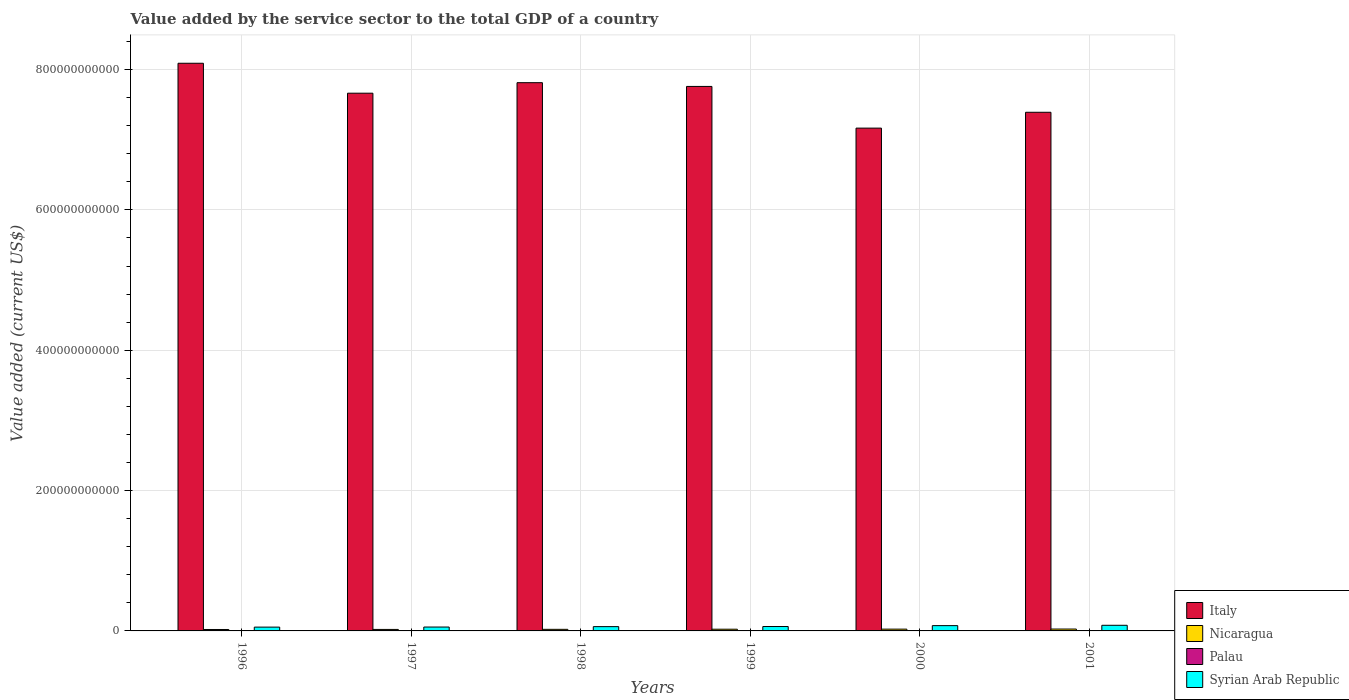How many different coloured bars are there?
Ensure brevity in your answer.  4. How many groups of bars are there?
Your response must be concise. 6. How many bars are there on the 5th tick from the left?
Make the answer very short. 4. How many bars are there on the 6th tick from the right?
Your response must be concise. 4. In how many cases, is the number of bars for a given year not equal to the number of legend labels?
Offer a terse response. 0. What is the value added by the service sector to the total GDP in Syrian Arab Republic in 2000?
Provide a succinct answer. 7.53e+09. Across all years, what is the maximum value added by the service sector to the total GDP in Italy?
Offer a terse response. 8.09e+11. Across all years, what is the minimum value added by the service sector to the total GDP in Nicaragua?
Offer a terse response. 2.03e+09. What is the total value added by the service sector to the total GDP in Palau in the graph?
Offer a very short reply. 5.96e+08. What is the difference between the value added by the service sector to the total GDP in Italy in 1996 and that in 1999?
Offer a terse response. 3.30e+1. What is the difference between the value added by the service sector to the total GDP in Italy in 2000 and the value added by the service sector to the total GDP in Palau in 1998?
Your answer should be compact. 7.16e+11. What is the average value added by the service sector to the total GDP in Syrian Arab Republic per year?
Your response must be concise. 6.48e+09. In the year 2000, what is the difference between the value added by the service sector to the total GDP in Nicaragua and value added by the service sector to the total GDP in Italy?
Provide a succinct answer. -7.14e+11. What is the ratio of the value added by the service sector to the total GDP in Palau in 1997 to that in 1998?
Ensure brevity in your answer.  1.01. Is the difference between the value added by the service sector to the total GDP in Nicaragua in 1996 and 2001 greater than the difference between the value added by the service sector to the total GDP in Italy in 1996 and 2001?
Offer a terse response. No. What is the difference between the highest and the second highest value added by the service sector to the total GDP in Italy?
Offer a very short reply. 2.77e+1. What is the difference between the highest and the lowest value added by the service sector to the total GDP in Nicaragua?
Ensure brevity in your answer.  6.43e+08. Is it the case that in every year, the sum of the value added by the service sector to the total GDP in Palau and value added by the service sector to the total GDP in Nicaragua is greater than the sum of value added by the service sector to the total GDP in Italy and value added by the service sector to the total GDP in Syrian Arab Republic?
Your answer should be compact. No. What does the 4th bar from the left in 1998 represents?
Provide a short and direct response. Syrian Arab Republic. What does the 1st bar from the right in 1997 represents?
Ensure brevity in your answer.  Syrian Arab Republic. Is it the case that in every year, the sum of the value added by the service sector to the total GDP in Syrian Arab Republic and value added by the service sector to the total GDP in Italy is greater than the value added by the service sector to the total GDP in Nicaragua?
Offer a very short reply. Yes. How many bars are there?
Make the answer very short. 24. How many years are there in the graph?
Your answer should be compact. 6. What is the difference between two consecutive major ticks on the Y-axis?
Give a very brief answer. 2.00e+11. Are the values on the major ticks of Y-axis written in scientific E-notation?
Offer a terse response. No. Does the graph contain any zero values?
Your answer should be compact. No. Does the graph contain grids?
Your response must be concise. Yes. What is the title of the graph?
Provide a succinct answer. Value added by the service sector to the total GDP of a country. Does "Zimbabwe" appear as one of the legend labels in the graph?
Provide a short and direct response. No. What is the label or title of the X-axis?
Offer a very short reply. Years. What is the label or title of the Y-axis?
Offer a very short reply. Value added (current US$). What is the Value added (current US$) in Italy in 1996?
Offer a terse response. 8.09e+11. What is the Value added (current US$) of Nicaragua in 1996?
Offer a terse response. 2.03e+09. What is the Value added (current US$) in Palau in 1996?
Provide a short and direct response. 9.31e+07. What is the Value added (current US$) in Syrian Arab Republic in 1996?
Give a very brief answer. 5.42e+09. What is the Value added (current US$) of Italy in 1997?
Give a very brief answer. 7.66e+11. What is the Value added (current US$) in Nicaragua in 1997?
Your answer should be compact. 2.13e+09. What is the Value added (current US$) in Palau in 1997?
Make the answer very short. 9.81e+07. What is the Value added (current US$) in Syrian Arab Republic in 1997?
Make the answer very short. 5.53e+09. What is the Value added (current US$) of Italy in 1998?
Your response must be concise. 7.81e+11. What is the Value added (current US$) in Nicaragua in 1998?
Offer a terse response. 2.26e+09. What is the Value added (current US$) in Palau in 1998?
Ensure brevity in your answer.  9.70e+07. What is the Value added (current US$) in Syrian Arab Republic in 1998?
Provide a succinct answer. 6.11e+09. What is the Value added (current US$) of Italy in 1999?
Provide a short and direct response. 7.76e+11. What is the Value added (current US$) in Nicaragua in 1999?
Make the answer very short. 2.44e+09. What is the Value added (current US$) of Palau in 1999?
Ensure brevity in your answer.  9.29e+07. What is the Value added (current US$) in Syrian Arab Republic in 1999?
Make the answer very short. 6.27e+09. What is the Value added (current US$) in Italy in 2000?
Your answer should be very brief. 7.16e+11. What is the Value added (current US$) of Nicaragua in 2000?
Provide a short and direct response. 2.54e+09. What is the Value added (current US$) in Palau in 2000?
Offer a terse response. 1.06e+08. What is the Value added (current US$) in Syrian Arab Republic in 2000?
Give a very brief answer. 7.53e+09. What is the Value added (current US$) of Italy in 2001?
Make the answer very short. 7.39e+11. What is the Value added (current US$) of Nicaragua in 2001?
Make the answer very short. 2.68e+09. What is the Value added (current US$) in Palau in 2001?
Give a very brief answer. 1.09e+08. What is the Value added (current US$) in Syrian Arab Republic in 2001?
Your answer should be compact. 8.02e+09. Across all years, what is the maximum Value added (current US$) of Italy?
Provide a succinct answer. 8.09e+11. Across all years, what is the maximum Value added (current US$) of Nicaragua?
Provide a succinct answer. 2.68e+09. Across all years, what is the maximum Value added (current US$) in Palau?
Ensure brevity in your answer.  1.09e+08. Across all years, what is the maximum Value added (current US$) in Syrian Arab Republic?
Keep it short and to the point. 8.02e+09. Across all years, what is the minimum Value added (current US$) of Italy?
Provide a succinct answer. 7.16e+11. Across all years, what is the minimum Value added (current US$) in Nicaragua?
Make the answer very short. 2.03e+09. Across all years, what is the minimum Value added (current US$) in Palau?
Offer a very short reply. 9.29e+07. Across all years, what is the minimum Value added (current US$) of Syrian Arab Republic?
Provide a short and direct response. 5.42e+09. What is the total Value added (current US$) in Italy in the graph?
Provide a succinct answer. 4.59e+12. What is the total Value added (current US$) of Nicaragua in the graph?
Keep it short and to the point. 1.41e+1. What is the total Value added (current US$) in Palau in the graph?
Your response must be concise. 5.96e+08. What is the total Value added (current US$) in Syrian Arab Republic in the graph?
Your response must be concise. 3.89e+1. What is the difference between the Value added (current US$) of Italy in 1996 and that in 1997?
Provide a succinct answer. 4.27e+1. What is the difference between the Value added (current US$) in Nicaragua in 1996 and that in 1997?
Provide a short and direct response. -9.48e+07. What is the difference between the Value added (current US$) in Palau in 1996 and that in 1997?
Your answer should be very brief. -5.01e+06. What is the difference between the Value added (current US$) of Syrian Arab Republic in 1996 and that in 1997?
Your response must be concise. -1.07e+08. What is the difference between the Value added (current US$) in Italy in 1996 and that in 1998?
Your answer should be compact. 2.77e+1. What is the difference between the Value added (current US$) of Nicaragua in 1996 and that in 1998?
Provide a short and direct response. -2.27e+08. What is the difference between the Value added (current US$) of Palau in 1996 and that in 1998?
Give a very brief answer. -3.92e+06. What is the difference between the Value added (current US$) in Syrian Arab Republic in 1996 and that in 1998?
Provide a short and direct response. -6.88e+08. What is the difference between the Value added (current US$) in Italy in 1996 and that in 1999?
Give a very brief answer. 3.30e+1. What is the difference between the Value added (current US$) of Nicaragua in 1996 and that in 1999?
Ensure brevity in your answer.  -4.00e+08. What is the difference between the Value added (current US$) in Palau in 1996 and that in 1999?
Your answer should be very brief. 1.87e+05. What is the difference between the Value added (current US$) of Syrian Arab Republic in 1996 and that in 1999?
Offer a terse response. -8.47e+08. What is the difference between the Value added (current US$) of Italy in 1996 and that in 2000?
Offer a terse response. 9.24e+1. What is the difference between the Value added (current US$) of Nicaragua in 1996 and that in 2000?
Ensure brevity in your answer.  -5.05e+08. What is the difference between the Value added (current US$) of Palau in 1996 and that in 2000?
Ensure brevity in your answer.  -1.26e+07. What is the difference between the Value added (current US$) of Syrian Arab Republic in 1996 and that in 2000?
Provide a short and direct response. -2.11e+09. What is the difference between the Value added (current US$) in Italy in 1996 and that in 2001?
Your answer should be compact. 6.98e+1. What is the difference between the Value added (current US$) in Nicaragua in 1996 and that in 2001?
Ensure brevity in your answer.  -6.43e+08. What is the difference between the Value added (current US$) in Palau in 1996 and that in 2001?
Offer a very short reply. -1.62e+07. What is the difference between the Value added (current US$) of Syrian Arab Republic in 1996 and that in 2001?
Offer a very short reply. -2.60e+09. What is the difference between the Value added (current US$) of Italy in 1997 and that in 1998?
Offer a very short reply. -1.50e+1. What is the difference between the Value added (current US$) of Nicaragua in 1997 and that in 1998?
Ensure brevity in your answer.  -1.32e+08. What is the difference between the Value added (current US$) in Palau in 1997 and that in 1998?
Give a very brief answer. 1.09e+06. What is the difference between the Value added (current US$) in Syrian Arab Republic in 1997 and that in 1998?
Keep it short and to the point. -5.80e+08. What is the difference between the Value added (current US$) in Italy in 1997 and that in 1999?
Keep it short and to the point. -9.65e+09. What is the difference between the Value added (current US$) in Nicaragua in 1997 and that in 1999?
Keep it short and to the point. -3.06e+08. What is the difference between the Value added (current US$) in Palau in 1997 and that in 1999?
Keep it short and to the point. 5.19e+06. What is the difference between the Value added (current US$) of Syrian Arab Republic in 1997 and that in 1999?
Your answer should be compact. -7.39e+08. What is the difference between the Value added (current US$) of Italy in 1997 and that in 2000?
Give a very brief answer. 4.98e+1. What is the difference between the Value added (current US$) in Nicaragua in 1997 and that in 2000?
Provide a short and direct response. -4.11e+08. What is the difference between the Value added (current US$) of Palau in 1997 and that in 2000?
Provide a short and direct response. -7.60e+06. What is the difference between the Value added (current US$) of Syrian Arab Republic in 1997 and that in 2000?
Offer a terse response. -2.00e+09. What is the difference between the Value added (current US$) of Italy in 1997 and that in 2001?
Keep it short and to the point. 2.72e+1. What is the difference between the Value added (current US$) in Nicaragua in 1997 and that in 2001?
Keep it short and to the point. -5.48e+08. What is the difference between the Value added (current US$) of Palau in 1997 and that in 2001?
Your answer should be compact. -1.11e+07. What is the difference between the Value added (current US$) of Syrian Arab Republic in 1997 and that in 2001?
Offer a terse response. -2.50e+09. What is the difference between the Value added (current US$) of Italy in 1998 and that in 1999?
Keep it short and to the point. 5.34e+09. What is the difference between the Value added (current US$) of Nicaragua in 1998 and that in 1999?
Your response must be concise. -1.74e+08. What is the difference between the Value added (current US$) in Palau in 1998 and that in 1999?
Provide a succinct answer. 4.11e+06. What is the difference between the Value added (current US$) of Syrian Arab Republic in 1998 and that in 1999?
Offer a very short reply. -1.59e+08. What is the difference between the Value added (current US$) in Italy in 1998 and that in 2000?
Your answer should be compact. 6.48e+1. What is the difference between the Value added (current US$) of Nicaragua in 1998 and that in 2000?
Offer a very short reply. -2.79e+08. What is the difference between the Value added (current US$) in Palau in 1998 and that in 2000?
Give a very brief answer. -8.68e+06. What is the difference between the Value added (current US$) of Syrian Arab Republic in 1998 and that in 2000?
Provide a short and direct response. -1.42e+09. What is the difference between the Value added (current US$) of Italy in 1998 and that in 2001?
Make the answer very short. 4.22e+1. What is the difference between the Value added (current US$) of Nicaragua in 1998 and that in 2001?
Keep it short and to the point. -4.16e+08. What is the difference between the Value added (current US$) in Palau in 1998 and that in 2001?
Keep it short and to the point. -1.22e+07. What is the difference between the Value added (current US$) of Syrian Arab Republic in 1998 and that in 2001?
Provide a short and direct response. -1.92e+09. What is the difference between the Value added (current US$) of Italy in 1999 and that in 2000?
Your answer should be compact. 5.94e+1. What is the difference between the Value added (current US$) in Nicaragua in 1999 and that in 2000?
Offer a very short reply. -1.05e+08. What is the difference between the Value added (current US$) of Palau in 1999 and that in 2000?
Keep it short and to the point. -1.28e+07. What is the difference between the Value added (current US$) in Syrian Arab Republic in 1999 and that in 2000?
Keep it short and to the point. -1.26e+09. What is the difference between the Value added (current US$) in Italy in 1999 and that in 2001?
Make the answer very short. 3.68e+1. What is the difference between the Value added (current US$) of Nicaragua in 1999 and that in 2001?
Ensure brevity in your answer.  -2.43e+08. What is the difference between the Value added (current US$) in Palau in 1999 and that in 2001?
Make the answer very short. -1.63e+07. What is the difference between the Value added (current US$) in Syrian Arab Republic in 1999 and that in 2001?
Make the answer very short. -1.76e+09. What is the difference between the Value added (current US$) of Italy in 2000 and that in 2001?
Make the answer very short. -2.26e+1. What is the difference between the Value added (current US$) in Nicaragua in 2000 and that in 2001?
Ensure brevity in your answer.  -1.38e+08. What is the difference between the Value added (current US$) of Palau in 2000 and that in 2001?
Make the answer very short. -3.55e+06. What is the difference between the Value added (current US$) of Syrian Arab Republic in 2000 and that in 2001?
Give a very brief answer. -4.96e+08. What is the difference between the Value added (current US$) of Italy in 1996 and the Value added (current US$) of Nicaragua in 1997?
Your answer should be very brief. 8.07e+11. What is the difference between the Value added (current US$) in Italy in 1996 and the Value added (current US$) in Palau in 1997?
Provide a succinct answer. 8.09e+11. What is the difference between the Value added (current US$) in Italy in 1996 and the Value added (current US$) in Syrian Arab Republic in 1997?
Ensure brevity in your answer.  8.03e+11. What is the difference between the Value added (current US$) in Nicaragua in 1996 and the Value added (current US$) in Palau in 1997?
Provide a succinct answer. 1.94e+09. What is the difference between the Value added (current US$) of Nicaragua in 1996 and the Value added (current US$) of Syrian Arab Republic in 1997?
Ensure brevity in your answer.  -3.49e+09. What is the difference between the Value added (current US$) in Palau in 1996 and the Value added (current US$) in Syrian Arab Republic in 1997?
Provide a succinct answer. -5.43e+09. What is the difference between the Value added (current US$) in Italy in 1996 and the Value added (current US$) in Nicaragua in 1998?
Keep it short and to the point. 8.07e+11. What is the difference between the Value added (current US$) in Italy in 1996 and the Value added (current US$) in Palau in 1998?
Your response must be concise. 8.09e+11. What is the difference between the Value added (current US$) in Italy in 1996 and the Value added (current US$) in Syrian Arab Republic in 1998?
Provide a short and direct response. 8.03e+11. What is the difference between the Value added (current US$) of Nicaragua in 1996 and the Value added (current US$) of Palau in 1998?
Offer a very short reply. 1.94e+09. What is the difference between the Value added (current US$) in Nicaragua in 1996 and the Value added (current US$) in Syrian Arab Republic in 1998?
Ensure brevity in your answer.  -4.07e+09. What is the difference between the Value added (current US$) in Palau in 1996 and the Value added (current US$) in Syrian Arab Republic in 1998?
Offer a very short reply. -6.01e+09. What is the difference between the Value added (current US$) in Italy in 1996 and the Value added (current US$) in Nicaragua in 1999?
Offer a very short reply. 8.06e+11. What is the difference between the Value added (current US$) in Italy in 1996 and the Value added (current US$) in Palau in 1999?
Offer a terse response. 8.09e+11. What is the difference between the Value added (current US$) in Italy in 1996 and the Value added (current US$) in Syrian Arab Republic in 1999?
Offer a terse response. 8.03e+11. What is the difference between the Value added (current US$) of Nicaragua in 1996 and the Value added (current US$) of Palau in 1999?
Provide a succinct answer. 1.94e+09. What is the difference between the Value added (current US$) in Nicaragua in 1996 and the Value added (current US$) in Syrian Arab Republic in 1999?
Offer a terse response. -4.23e+09. What is the difference between the Value added (current US$) of Palau in 1996 and the Value added (current US$) of Syrian Arab Republic in 1999?
Make the answer very short. -6.17e+09. What is the difference between the Value added (current US$) of Italy in 1996 and the Value added (current US$) of Nicaragua in 2000?
Provide a succinct answer. 8.06e+11. What is the difference between the Value added (current US$) in Italy in 1996 and the Value added (current US$) in Palau in 2000?
Make the answer very short. 8.09e+11. What is the difference between the Value added (current US$) of Italy in 1996 and the Value added (current US$) of Syrian Arab Republic in 2000?
Provide a short and direct response. 8.01e+11. What is the difference between the Value added (current US$) of Nicaragua in 1996 and the Value added (current US$) of Palau in 2000?
Your response must be concise. 1.93e+09. What is the difference between the Value added (current US$) of Nicaragua in 1996 and the Value added (current US$) of Syrian Arab Republic in 2000?
Ensure brevity in your answer.  -5.49e+09. What is the difference between the Value added (current US$) in Palau in 1996 and the Value added (current US$) in Syrian Arab Republic in 2000?
Keep it short and to the point. -7.43e+09. What is the difference between the Value added (current US$) in Italy in 1996 and the Value added (current US$) in Nicaragua in 2001?
Your answer should be very brief. 8.06e+11. What is the difference between the Value added (current US$) of Italy in 1996 and the Value added (current US$) of Palau in 2001?
Provide a succinct answer. 8.09e+11. What is the difference between the Value added (current US$) of Italy in 1996 and the Value added (current US$) of Syrian Arab Republic in 2001?
Give a very brief answer. 8.01e+11. What is the difference between the Value added (current US$) in Nicaragua in 1996 and the Value added (current US$) in Palau in 2001?
Offer a terse response. 1.93e+09. What is the difference between the Value added (current US$) of Nicaragua in 1996 and the Value added (current US$) of Syrian Arab Republic in 2001?
Your answer should be very brief. -5.99e+09. What is the difference between the Value added (current US$) in Palau in 1996 and the Value added (current US$) in Syrian Arab Republic in 2001?
Ensure brevity in your answer.  -7.93e+09. What is the difference between the Value added (current US$) of Italy in 1997 and the Value added (current US$) of Nicaragua in 1998?
Your answer should be compact. 7.64e+11. What is the difference between the Value added (current US$) in Italy in 1997 and the Value added (current US$) in Palau in 1998?
Give a very brief answer. 7.66e+11. What is the difference between the Value added (current US$) in Italy in 1997 and the Value added (current US$) in Syrian Arab Republic in 1998?
Keep it short and to the point. 7.60e+11. What is the difference between the Value added (current US$) of Nicaragua in 1997 and the Value added (current US$) of Palau in 1998?
Give a very brief answer. 2.03e+09. What is the difference between the Value added (current US$) in Nicaragua in 1997 and the Value added (current US$) in Syrian Arab Republic in 1998?
Offer a very short reply. -3.98e+09. What is the difference between the Value added (current US$) of Palau in 1997 and the Value added (current US$) of Syrian Arab Republic in 1998?
Offer a very short reply. -6.01e+09. What is the difference between the Value added (current US$) in Italy in 1997 and the Value added (current US$) in Nicaragua in 1999?
Your answer should be compact. 7.64e+11. What is the difference between the Value added (current US$) in Italy in 1997 and the Value added (current US$) in Palau in 1999?
Provide a succinct answer. 7.66e+11. What is the difference between the Value added (current US$) in Italy in 1997 and the Value added (current US$) in Syrian Arab Republic in 1999?
Give a very brief answer. 7.60e+11. What is the difference between the Value added (current US$) of Nicaragua in 1997 and the Value added (current US$) of Palau in 1999?
Give a very brief answer. 2.04e+09. What is the difference between the Value added (current US$) of Nicaragua in 1997 and the Value added (current US$) of Syrian Arab Republic in 1999?
Make the answer very short. -4.14e+09. What is the difference between the Value added (current US$) in Palau in 1997 and the Value added (current US$) in Syrian Arab Republic in 1999?
Offer a very short reply. -6.17e+09. What is the difference between the Value added (current US$) in Italy in 1997 and the Value added (current US$) in Nicaragua in 2000?
Your response must be concise. 7.64e+11. What is the difference between the Value added (current US$) of Italy in 1997 and the Value added (current US$) of Palau in 2000?
Make the answer very short. 7.66e+11. What is the difference between the Value added (current US$) in Italy in 1997 and the Value added (current US$) in Syrian Arab Republic in 2000?
Provide a short and direct response. 7.59e+11. What is the difference between the Value added (current US$) of Nicaragua in 1997 and the Value added (current US$) of Palau in 2000?
Make the answer very short. 2.02e+09. What is the difference between the Value added (current US$) in Nicaragua in 1997 and the Value added (current US$) in Syrian Arab Republic in 2000?
Keep it short and to the point. -5.40e+09. What is the difference between the Value added (current US$) in Palau in 1997 and the Value added (current US$) in Syrian Arab Republic in 2000?
Make the answer very short. -7.43e+09. What is the difference between the Value added (current US$) in Italy in 1997 and the Value added (current US$) in Nicaragua in 2001?
Offer a very short reply. 7.64e+11. What is the difference between the Value added (current US$) of Italy in 1997 and the Value added (current US$) of Palau in 2001?
Give a very brief answer. 7.66e+11. What is the difference between the Value added (current US$) of Italy in 1997 and the Value added (current US$) of Syrian Arab Republic in 2001?
Keep it short and to the point. 7.58e+11. What is the difference between the Value added (current US$) in Nicaragua in 1997 and the Value added (current US$) in Palau in 2001?
Your answer should be compact. 2.02e+09. What is the difference between the Value added (current US$) of Nicaragua in 1997 and the Value added (current US$) of Syrian Arab Republic in 2001?
Your answer should be very brief. -5.89e+09. What is the difference between the Value added (current US$) of Palau in 1997 and the Value added (current US$) of Syrian Arab Republic in 2001?
Offer a terse response. -7.92e+09. What is the difference between the Value added (current US$) in Italy in 1998 and the Value added (current US$) in Nicaragua in 1999?
Your response must be concise. 7.79e+11. What is the difference between the Value added (current US$) of Italy in 1998 and the Value added (current US$) of Palau in 1999?
Offer a terse response. 7.81e+11. What is the difference between the Value added (current US$) of Italy in 1998 and the Value added (current US$) of Syrian Arab Republic in 1999?
Your response must be concise. 7.75e+11. What is the difference between the Value added (current US$) of Nicaragua in 1998 and the Value added (current US$) of Palau in 1999?
Your response must be concise. 2.17e+09. What is the difference between the Value added (current US$) in Nicaragua in 1998 and the Value added (current US$) in Syrian Arab Republic in 1999?
Give a very brief answer. -4.00e+09. What is the difference between the Value added (current US$) in Palau in 1998 and the Value added (current US$) in Syrian Arab Republic in 1999?
Your answer should be very brief. -6.17e+09. What is the difference between the Value added (current US$) of Italy in 1998 and the Value added (current US$) of Nicaragua in 2000?
Ensure brevity in your answer.  7.79e+11. What is the difference between the Value added (current US$) of Italy in 1998 and the Value added (current US$) of Palau in 2000?
Your answer should be very brief. 7.81e+11. What is the difference between the Value added (current US$) in Italy in 1998 and the Value added (current US$) in Syrian Arab Republic in 2000?
Your answer should be very brief. 7.74e+11. What is the difference between the Value added (current US$) in Nicaragua in 1998 and the Value added (current US$) in Palau in 2000?
Ensure brevity in your answer.  2.16e+09. What is the difference between the Value added (current US$) in Nicaragua in 1998 and the Value added (current US$) in Syrian Arab Republic in 2000?
Keep it short and to the point. -5.26e+09. What is the difference between the Value added (current US$) in Palau in 1998 and the Value added (current US$) in Syrian Arab Republic in 2000?
Give a very brief answer. -7.43e+09. What is the difference between the Value added (current US$) in Italy in 1998 and the Value added (current US$) in Nicaragua in 2001?
Your answer should be very brief. 7.79e+11. What is the difference between the Value added (current US$) in Italy in 1998 and the Value added (current US$) in Palau in 2001?
Give a very brief answer. 7.81e+11. What is the difference between the Value added (current US$) of Italy in 1998 and the Value added (current US$) of Syrian Arab Republic in 2001?
Offer a very short reply. 7.73e+11. What is the difference between the Value added (current US$) in Nicaragua in 1998 and the Value added (current US$) in Palau in 2001?
Your answer should be compact. 2.15e+09. What is the difference between the Value added (current US$) of Nicaragua in 1998 and the Value added (current US$) of Syrian Arab Republic in 2001?
Provide a succinct answer. -5.76e+09. What is the difference between the Value added (current US$) of Palau in 1998 and the Value added (current US$) of Syrian Arab Republic in 2001?
Ensure brevity in your answer.  -7.92e+09. What is the difference between the Value added (current US$) in Italy in 1999 and the Value added (current US$) in Nicaragua in 2000?
Offer a very short reply. 7.73e+11. What is the difference between the Value added (current US$) of Italy in 1999 and the Value added (current US$) of Palau in 2000?
Ensure brevity in your answer.  7.76e+11. What is the difference between the Value added (current US$) of Italy in 1999 and the Value added (current US$) of Syrian Arab Republic in 2000?
Give a very brief answer. 7.68e+11. What is the difference between the Value added (current US$) in Nicaragua in 1999 and the Value added (current US$) in Palau in 2000?
Offer a very short reply. 2.33e+09. What is the difference between the Value added (current US$) of Nicaragua in 1999 and the Value added (current US$) of Syrian Arab Republic in 2000?
Offer a terse response. -5.09e+09. What is the difference between the Value added (current US$) in Palau in 1999 and the Value added (current US$) in Syrian Arab Republic in 2000?
Provide a short and direct response. -7.43e+09. What is the difference between the Value added (current US$) in Italy in 1999 and the Value added (current US$) in Nicaragua in 2001?
Your response must be concise. 7.73e+11. What is the difference between the Value added (current US$) in Italy in 1999 and the Value added (current US$) in Palau in 2001?
Offer a terse response. 7.76e+11. What is the difference between the Value added (current US$) of Italy in 1999 and the Value added (current US$) of Syrian Arab Republic in 2001?
Give a very brief answer. 7.68e+11. What is the difference between the Value added (current US$) in Nicaragua in 1999 and the Value added (current US$) in Palau in 2001?
Give a very brief answer. 2.33e+09. What is the difference between the Value added (current US$) of Nicaragua in 1999 and the Value added (current US$) of Syrian Arab Republic in 2001?
Your response must be concise. -5.59e+09. What is the difference between the Value added (current US$) of Palau in 1999 and the Value added (current US$) of Syrian Arab Republic in 2001?
Give a very brief answer. -7.93e+09. What is the difference between the Value added (current US$) of Italy in 2000 and the Value added (current US$) of Nicaragua in 2001?
Your response must be concise. 7.14e+11. What is the difference between the Value added (current US$) of Italy in 2000 and the Value added (current US$) of Palau in 2001?
Keep it short and to the point. 7.16e+11. What is the difference between the Value added (current US$) of Italy in 2000 and the Value added (current US$) of Syrian Arab Republic in 2001?
Offer a very short reply. 7.08e+11. What is the difference between the Value added (current US$) of Nicaragua in 2000 and the Value added (current US$) of Palau in 2001?
Offer a very short reply. 2.43e+09. What is the difference between the Value added (current US$) in Nicaragua in 2000 and the Value added (current US$) in Syrian Arab Republic in 2001?
Make the answer very short. -5.48e+09. What is the difference between the Value added (current US$) of Palau in 2000 and the Value added (current US$) of Syrian Arab Republic in 2001?
Your answer should be compact. -7.92e+09. What is the average Value added (current US$) in Italy per year?
Provide a succinct answer. 7.65e+11. What is the average Value added (current US$) of Nicaragua per year?
Your response must be concise. 2.35e+09. What is the average Value added (current US$) of Palau per year?
Your answer should be compact. 9.94e+07. What is the average Value added (current US$) of Syrian Arab Republic per year?
Your answer should be very brief. 6.48e+09. In the year 1996, what is the difference between the Value added (current US$) in Italy and Value added (current US$) in Nicaragua?
Provide a succinct answer. 8.07e+11. In the year 1996, what is the difference between the Value added (current US$) of Italy and Value added (current US$) of Palau?
Offer a terse response. 8.09e+11. In the year 1996, what is the difference between the Value added (current US$) of Italy and Value added (current US$) of Syrian Arab Republic?
Offer a very short reply. 8.03e+11. In the year 1996, what is the difference between the Value added (current US$) of Nicaragua and Value added (current US$) of Palau?
Make the answer very short. 1.94e+09. In the year 1996, what is the difference between the Value added (current US$) in Nicaragua and Value added (current US$) in Syrian Arab Republic?
Keep it short and to the point. -3.38e+09. In the year 1996, what is the difference between the Value added (current US$) in Palau and Value added (current US$) in Syrian Arab Republic?
Ensure brevity in your answer.  -5.33e+09. In the year 1997, what is the difference between the Value added (current US$) of Italy and Value added (current US$) of Nicaragua?
Make the answer very short. 7.64e+11. In the year 1997, what is the difference between the Value added (current US$) of Italy and Value added (current US$) of Palau?
Give a very brief answer. 7.66e+11. In the year 1997, what is the difference between the Value added (current US$) of Italy and Value added (current US$) of Syrian Arab Republic?
Your answer should be compact. 7.61e+11. In the year 1997, what is the difference between the Value added (current US$) in Nicaragua and Value added (current US$) in Palau?
Ensure brevity in your answer.  2.03e+09. In the year 1997, what is the difference between the Value added (current US$) of Nicaragua and Value added (current US$) of Syrian Arab Republic?
Provide a short and direct response. -3.40e+09. In the year 1997, what is the difference between the Value added (current US$) in Palau and Value added (current US$) in Syrian Arab Republic?
Your answer should be compact. -5.43e+09. In the year 1998, what is the difference between the Value added (current US$) in Italy and Value added (current US$) in Nicaragua?
Give a very brief answer. 7.79e+11. In the year 1998, what is the difference between the Value added (current US$) in Italy and Value added (current US$) in Palau?
Make the answer very short. 7.81e+11. In the year 1998, what is the difference between the Value added (current US$) in Italy and Value added (current US$) in Syrian Arab Republic?
Ensure brevity in your answer.  7.75e+11. In the year 1998, what is the difference between the Value added (current US$) in Nicaragua and Value added (current US$) in Palau?
Ensure brevity in your answer.  2.16e+09. In the year 1998, what is the difference between the Value added (current US$) of Nicaragua and Value added (current US$) of Syrian Arab Republic?
Your answer should be compact. -3.84e+09. In the year 1998, what is the difference between the Value added (current US$) of Palau and Value added (current US$) of Syrian Arab Republic?
Offer a very short reply. -6.01e+09. In the year 1999, what is the difference between the Value added (current US$) of Italy and Value added (current US$) of Nicaragua?
Your answer should be very brief. 7.73e+11. In the year 1999, what is the difference between the Value added (current US$) in Italy and Value added (current US$) in Palau?
Your answer should be very brief. 7.76e+11. In the year 1999, what is the difference between the Value added (current US$) in Italy and Value added (current US$) in Syrian Arab Republic?
Provide a short and direct response. 7.70e+11. In the year 1999, what is the difference between the Value added (current US$) in Nicaragua and Value added (current US$) in Palau?
Provide a succinct answer. 2.34e+09. In the year 1999, what is the difference between the Value added (current US$) in Nicaragua and Value added (current US$) in Syrian Arab Republic?
Your answer should be very brief. -3.83e+09. In the year 1999, what is the difference between the Value added (current US$) in Palau and Value added (current US$) in Syrian Arab Republic?
Keep it short and to the point. -6.17e+09. In the year 2000, what is the difference between the Value added (current US$) of Italy and Value added (current US$) of Nicaragua?
Give a very brief answer. 7.14e+11. In the year 2000, what is the difference between the Value added (current US$) of Italy and Value added (current US$) of Palau?
Keep it short and to the point. 7.16e+11. In the year 2000, what is the difference between the Value added (current US$) in Italy and Value added (current US$) in Syrian Arab Republic?
Provide a short and direct response. 7.09e+11. In the year 2000, what is the difference between the Value added (current US$) in Nicaragua and Value added (current US$) in Palau?
Provide a succinct answer. 2.43e+09. In the year 2000, what is the difference between the Value added (current US$) in Nicaragua and Value added (current US$) in Syrian Arab Republic?
Offer a terse response. -4.99e+09. In the year 2000, what is the difference between the Value added (current US$) in Palau and Value added (current US$) in Syrian Arab Republic?
Offer a very short reply. -7.42e+09. In the year 2001, what is the difference between the Value added (current US$) of Italy and Value added (current US$) of Nicaragua?
Offer a terse response. 7.36e+11. In the year 2001, what is the difference between the Value added (current US$) of Italy and Value added (current US$) of Palau?
Offer a very short reply. 7.39e+11. In the year 2001, what is the difference between the Value added (current US$) in Italy and Value added (current US$) in Syrian Arab Republic?
Keep it short and to the point. 7.31e+11. In the year 2001, what is the difference between the Value added (current US$) in Nicaragua and Value added (current US$) in Palau?
Give a very brief answer. 2.57e+09. In the year 2001, what is the difference between the Value added (current US$) of Nicaragua and Value added (current US$) of Syrian Arab Republic?
Make the answer very short. -5.34e+09. In the year 2001, what is the difference between the Value added (current US$) of Palau and Value added (current US$) of Syrian Arab Republic?
Your response must be concise. -7.91e+09. What is the ratio of the Value added (current US$) in Italy in 1996 to that in 1997?
Give a very brief answer. 1.06. What is the ratio of the Value added (current US$) in Nicaragua in 1996 to that in 1997?
Make the answer very short. 0.96. What is the ratio of the Value added (current US$) of Palau in 1996 to that in 1997?
Keep it short and to the point. 0.95. What is the ratio of the Value added (current US$) in Syrian Arab Republic in 1996 to that in 1997?
Your answer should be very brief. 0.98. What is the ratio of the Value added (current US$) of Italy in 1996 to that in 1998?
Offer a very short reply. 1.04. What is the ratio of the Value added (current US$) of Nicaragua in 1996 to that in 1998?
Make the answer very short. 0.9. What is the ratio of the Value added (current US$) in Palau in 1996 to that in 1998?
Your answer should be very brief. 0.96. What is the ratio of the Value added (current US$) in Syrian Arab Republic in 1996 to that in 1998?
Give a very brief answer. 0.89. What is the ratio of the Value added (current US$) in Italy in 1996 to that in 1999?
Your answer should be very brief. 1.04. What is the ratio of the Value added (current US$) of Nicaragua in 1996 to that in 1999?
Make the answer very short. 0.84. What is the ratio of the Value added (current US$) of Syrian Arab Republic in 1996 to that in 1999?
Provide a succinct answer. 0.86. What is the ratio of the Value added (current US$) in Italy in 1996 to that in 2000?
Make the answer very short. 1.13. What is the ratio of the Value added (current US$) in Nicaragua in 1996 to that in 2000?
Offer a terse response. 0.8. What is the ratio of the Value added (current US$) of Palau in 1996 to that in 2000?
Give a very brief answer. 0.88. What is the ratio of the Value added (current US$) of Syrian Arab Republic in 1996 to that in 2000?
Keep it short and to the point. 0.72. What is the ratio of the Value added (current US$) of Italy in 1996 to that in 2001?
Offer a terse response. 1.09. What is the ratio of the Value added (current US$) in Nicaragua in 1996 to that in 2001?
Ensure brevity in your answer.  0.76. What is the ratio of the Value added (current US$) in Palau in 1996 to that in 2001?
Provide a short and direct response. 0.85. What is the ratio of the Value added (current US$) of Syrian Arab Republic in 1996 to that in 2001?
Make the answer very short. 0.68. What is the ratio of the Value added (current US$) of Italy in 1997 to that in 1998?
Provide a short and direct response. 0.98. What is the ratio of the Value added (current US$) in Nicaragua in 1997 to that in 1998?
Make the answer very short. 0.94. What is the ratio of the Value added (current US$) in Palau in 1997 to that in 1998?
Keep it short and to the point. 1.01. What is the ratio of the Value added (current US$) in Syrian Arab Republic in 1997 to that in 1998?
Offer a terse response. 0.91. What is the ratio of the Value added (current US$) in Italy in 1997 to that in 1999?
Offer a very short reply. 0.99. What is the ratio of the Value added (current US$) in Nicaragua in 1997 to that in 1999?
Make the answer very short. 0.87. What is the ratio of the Value added (current US$) of Palau in 1997 to that in 1999?
Give a very brief answer. 1.06. What is the ratio of the Value added (current US$) in Syrian Arab Republic in 1997 to that in 1999?
Provide a succinct answer. 0.88. What is the ratio of the Value added (current US$) of Italy in 1997 to that in 2000?
Ensure brevity in your answer.  1.07. What is the ratio of the Value added (current US$) in Nicaragua in 1997 to that in 2000?
Offer a very short reply. 0.84. What is the ratio of the Value added (current US$) of Palau in 1997 to that in 2000?
Keep it short and to the point. 0.93. What is the ratio of the Value added (current US$) in Syrian Arab Republic in 1997 to that in 2000?
Your response must be concise. 0.73. What is the ratio of the Value added (current US$) of Italy in 1997 to that in 2001?
Provide a succinct answer. 1.04. What is the ratio of the Value added (current US$) in Nicaragua in 1997 to that in 2001?
Keep it short and to the point. 0.8. What is the ratio of the Value added (current US$) in Palau in 1997 to that in 2001?
Your answer should be compact. 0.9. What is the ratio of the Value added (current US$) of Syrian Arab Republic in 1997 to that in 2001?
Keep it short and to the point. 0.69. What is the ratio of the Value added (current US$) of Italy in 1998 to that in 1999?
Keep it short and to the point. 1.01. What is the ratio of the Value added (current US$) in Nicaragua in 1998 to that in 1999?
Make the answer very short. 0.93. What is the ratio of the Value added (current US$) in Palau in 1998 to that in 1999?
Provide a short and direct response. 1.04. What is the ratio of the Value added (current US$) of Syrian Arab Republic in 1998 to that in 1999?
Offer a terse response. 0.97. What is the ratio of the Value added (current US$) of Italy in 1998 to that in 2000?
Provide a short and direct response. 1.09. What is the ratio of the Value added (current US$) in Nicaragua in 1998 to that in 2000?
Provide a succinct answer. 0.89. What is the ratio of the Value added (current US$) in Palau in 1998 to that in 2000?
Give a very brief answer. 0.92. What is the ratio of the Value added (current US$) of Syrian Arab Republic in 1998 to that in 2000?
Keep it short and to the point. 0.81. What is the ratio of the Value added (current US$) in Italy in 1998 to that in 2001?
Provide a succinct answer. 1.06. What is the ratio of the Value added (current US$) in Nicaragua in 1998 to that in 2001?
Keep it short and to the point. 0.84. What is the ratio of the Value added (current US$) of Palau in 1998 to that in 2001?
Ensure brevity in your answer.  0.89. What is the ratio of the Value added (current US$) in Syrian Arab Republic in 1998 to that in 2001?
Provide a short and direct response. 0.76. What is the ratio of the Value added (current US$) of Italy in 1999 to that in 2000?
Offer a very short reply. 1.08. What is the ratio of the Value added (current US$) of Nicaragua in 1999 to that in 2000?
Offer a very short reply. 0.96. What is the ratio of the Value added (current US$) in Palau in 1999 to that in 2000?
Give a very brief answer. 0.88. What is the ratio of the Value added (current US$) of Syrian Arab Republic in 1999 to that in 2000?
Provide a succinct answer. 0.83. What is the ratio of the Value added (current US$) of Italy in 1999 to that in 2001?
Your answer should be compact. 1.05. What is the ratio of the Value added (current US$) in Nicaragua in 1999 to that in 2001?
Offer a terse response. 0.91. What is the ratio of the Value added (current US$) of Palau in 1999 to that in 2001?
Your answer should be very brief. 0.85. What is the ratio of the Value added (current US$) of Syrian Arab Republic in 1999 to that in 2001?
Make the answer very short. 0.78. What is the ratio of the Value added (current US$) of Italy in 2000 to that in 2001?
Keep it short and to the point. 0.97. What is the ratio of the Value added (current US$) of Nicaragua in 2000 to that in 2001?
Provide a succinct answer. 0.95. What is the ratio of the Value added (current US$) in Palau in 2000 to that in 2001?
Provide a succinct answer. 0.97. What is the ratio of the Value added (current US$) in Syrian Arab Republic in 2000 to that in 2001?
Ensure brevity in your answer.  0.94. What is the difference between the highest and the second highest Value added (current US$) in Italy?
Your answer should be compact. 2.77e+1. What is the difference between the highest and the second highest Value added (current US$) of Nicaragua?
Offer a terse response. 1.38e+08. What is the difference between the highest and the second highest Value added (current US$) in Palau?
Provide a short and direct response. 3.55e+06. What is the difference between the highest and the second highest Value added (current US$) in Syrian Arab Republic?
Ensure brevity in your answer.  4.96e+08. What is the difference between the highest and the lowest Value added (current US$) of Italy?
Ensure brevity in your answer.  9.24e+1. What is the difference between the highest and the lowest Value added (current US$) of Nicaragua?
Provide a short and direct response. 6.43e+08. What is the difference between the highest and the lowest Value added (current US$) of Palau?
Make the answer very short. 1.63e+07. What is the difference between the highest and the lowest Value added (current US$) of Syrian Arab Republic?
Keep it short and to the point. 2.60e+09. 